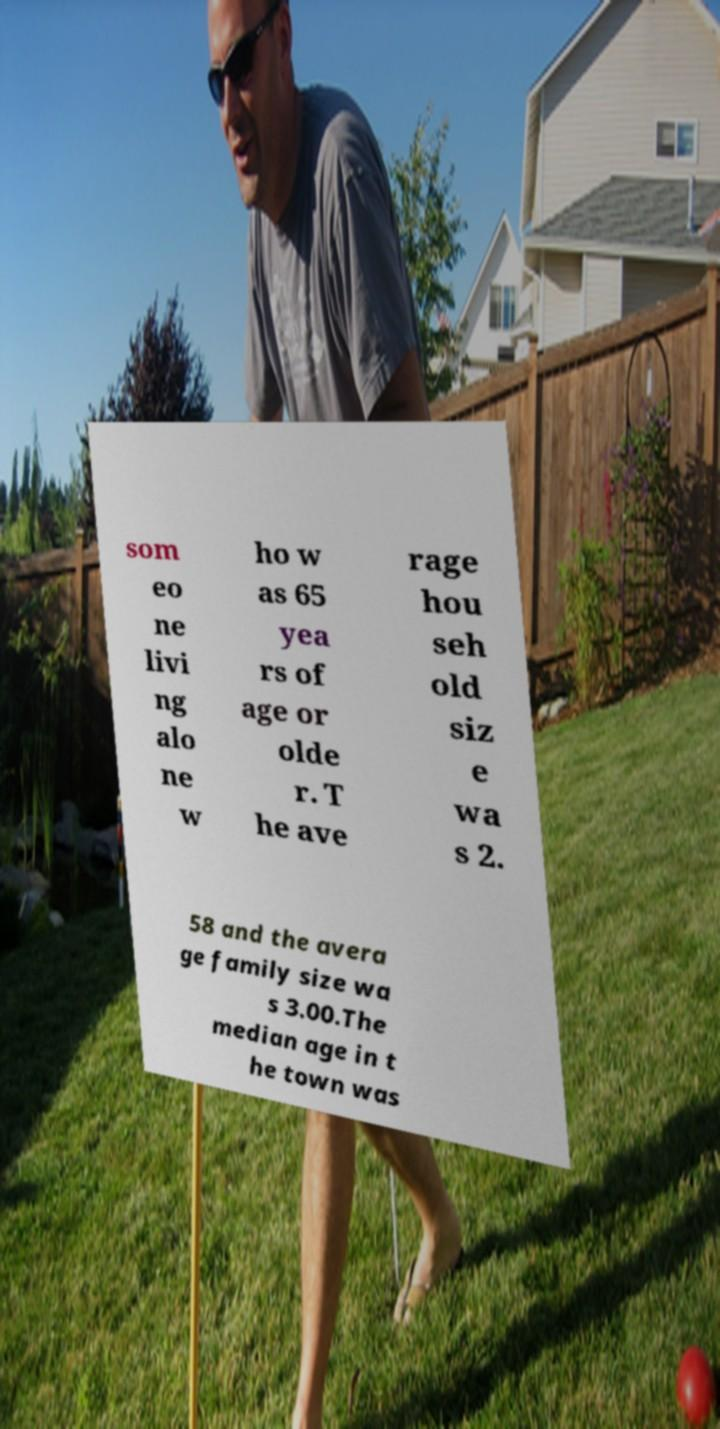I need the written content from this picture converted into text. Can you do that? som eo ne livi ng alo ne w ho w as 65 yea rs of age or olde r. T he ave rage hou seh old siz e wa s 2. 58 and the avera ge family size wa s 3.00.The median age in t he town was 